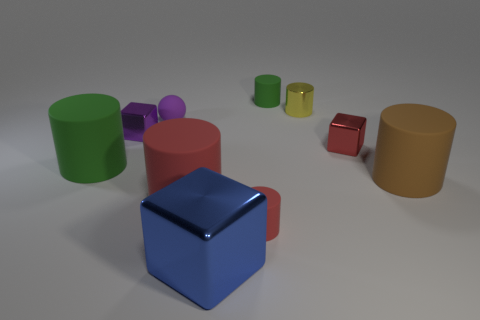How many green cylinders must be subtracted to get 1 green cylinders? 1 Subtract all yellow cylinders. How many cylinders are left? 5 Subtract all large red cylinders. How many cylinders are left? 5 Subtract all cyan cylinders. Subtract all purple blocks. How many cylinders are left? 6 Subtract all blocks. How many objects are left? 7 Add 5 small rubber balls. How many small rubber balls are left? 6 Add 1 large blue shiny things. How many large blue shiny things exist? 2 Subtract 1 purple balls. How many objects are left? 9 Subtract all big things. Subtract all purple shiny objects. How many objects are left? 5 